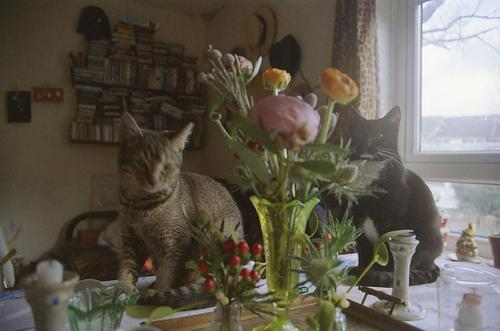Express the scene captured in the image using poetic language. The grey feline and its monochromatic counterpart reside in a world of beauty, wherein flora bloom from jade vases as candlelight dances, and leopard print curtains frame the stage. Mention the two main animals featured in the image and their unique attributes. There is a grey cat with a neutral expression and a black cat with a white chest, both sitting on a table filled with decorative objects. Write a brief summary of the image in a news reporter style. Today's special feature is a snapshot of two cats living amidst a stunning exhibition of decorative objects, including vases with flowers and foliage, a candle holder, books, and leopard print curtains, making for a striking visual story. Imagine you are a real estate agent and describe the image as a room in a house. This captivating room features a beautifully arranged table with vases of flowers, a unique candle holder, and other stunning decor. The charming presence of two cats adds life and warmth to the delightful space. Describe the image from the perspective of an art critic. This intriguing composition elegantly juxtaposes the feline subjects with a rich tableau of eclectic decor, including vases that hold blossoms, a candle holder, and leopard print curtains, resulting in a harmonic medley of form and color. Summarize the picture with an emphasis on the variety of decorations. This image displays a vivid assortment of decor, including vases with flowers, a candle holder, hats, books, and leopard print curtains, with two cats adding life to the assemblage. Describe the image focusing on the key objects and their details present in it. The image shows a table adorned with vases of flowers, red berries, and a candle holder, accompanied by two cats, one grey and the other black and white. Books, hats, and cheetah print curtains contribute to the scenery. Provide an overview of the scene depicted in the image, highlighting the role of the cats. In a cozy setting filled with decorative objects like vases, flowers, and leopard print curtains, two cats bring animation to the scene as they sit on the table amidst the vibrant display. Identify the key elements in the image and provide a brief description. Two cats, one grey and the other black and white, are sitting on a table with various vases, flowers, and a candle holder, while other decorative elements like hats, books, and leopard print curtains complete the scene. Narrate a short story of the two animals' interaction with their environment in the image. Once upon a time, there were two curious cats who ventured onto a table adorned with a striking collection of decor. Surrounded by vases, flowers, and the warm glow of a candle, they marveled at their vibrant new playground. 